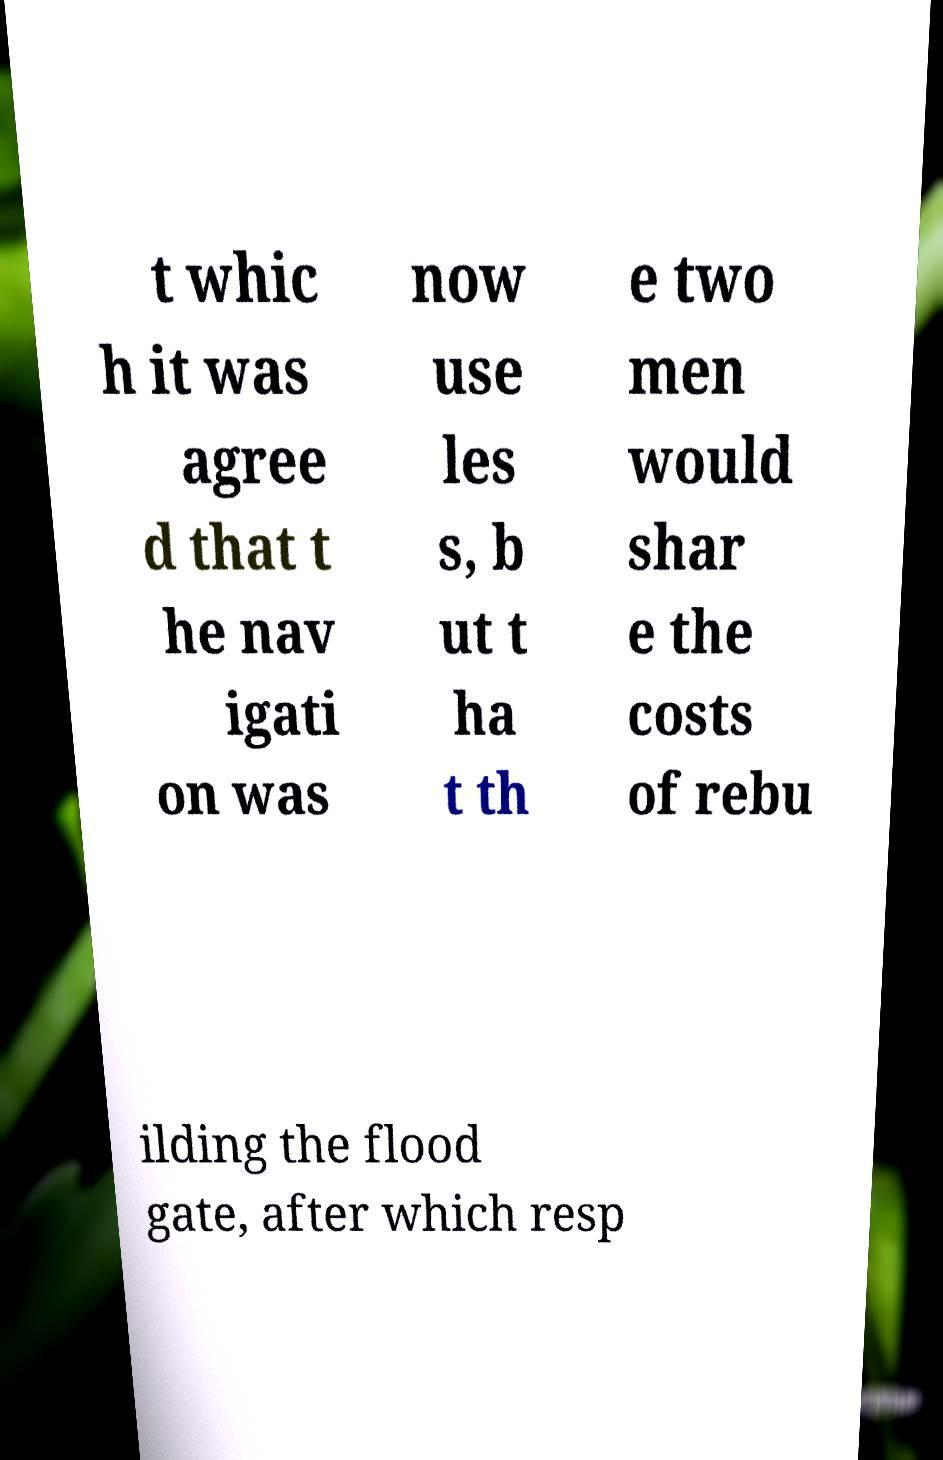What messages or text are displayed in this image? I need them in a readable, typed format. t whic h it was agree d that t he nav igati on was now use les s, b ut t ha t th e two men would shar e the costs of rebu ilding the flood gate, after which resp 